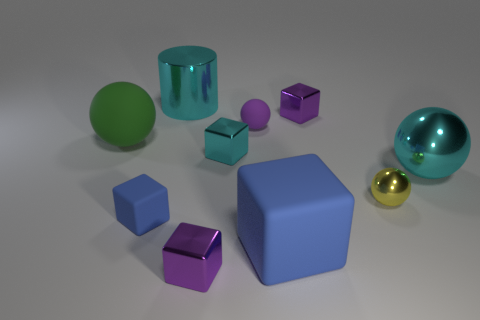Does the large metallic cylinder have the same color as the big shiny sphere?
Offer a terse response. Yes. What number of balls are both on the right side of the purple rubber sphere and behind the yellow thing?
Your answer should be very brief. 1. There is a blue object to the left of the metal cylinder; what shape is it?
Your answer should be very brief. Cube. Are there fewer cyan shiny things that are right of the large block than large shiny spheres that are to the left of the small yellow object?
Provide a short and direct response. No. Is the material of the purple object in front of the tiny yellow sphere the same as the big blue block in front of the large green rubber thing?
Offer a very short reply. No. There is a tiny cyan metallic object; what shape is it?
Offer a very short reply. Cube. Is the number of cyan metallic things that are on the right side of the large cube greater than the number of green objects that are behind the tiny purple ball?
Make the answer very short. Yes. Do the tiny purple shiny object that is to the right of the small purple rubber sphere and the small rubber object that is in front of the yellow thing have the same shape?
Your answer should be compact. Yes. How many other objects are the same size as the yellow metallic sphere?
Keep it short and to the point. 5. What is the size of the cyan metallic sphere?
Ensure brevity in your answer.  Large. 